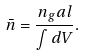Convert formula to latex. <formula><loc_0><loc_0><loc_500><loc_500>\bar { n } = \frac { n _ { g } a l } { \int d V } .</formula> 